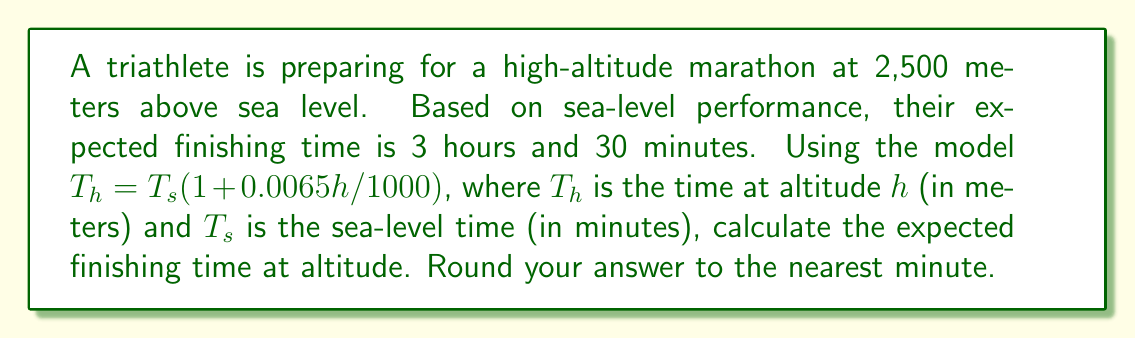Teach me how to tackle this problem. To solve this problem, we'll follow these steps:

1. Convert the sea-level time to minutes:
   $T_s = 3 \text{ hours } 30 \text{ minutes} = 3 \times 60 + 30 = 210 \text{ minutes}$

2. Use the given model to calculate the time at altitude:
   $$T_h = T_s(1 + 0.0065h/1000)$$
   
   Where:
   $T_h$ is the time at altitude (in minutes)
   $T_s = 210$ minutes (sea-level time)
   $h = 2500$ meters (altitude)

3. Substitute the values into the equation:
   $$T_h = 210(1 + 0.0065 \times 2500/1000)$$

4. Simplify:
   $$T_h = 210(1 + 0.01625)$$
   $$T_h = 210 \times 1.01625$$
   $$T_h = 213.4125 \text{ minutes}$$

5. Round to the nearest minute:
   $T_h \approx 213 \text{ minutes}$

6. Convert back to hours and minutes:
   213 minutes = 3 hours 33 minutes

Therefore, the expected finishing time at 2,500 meters altitude is 3 hours and 33 minutes.
Answer: 3 hours and 33 minutes 